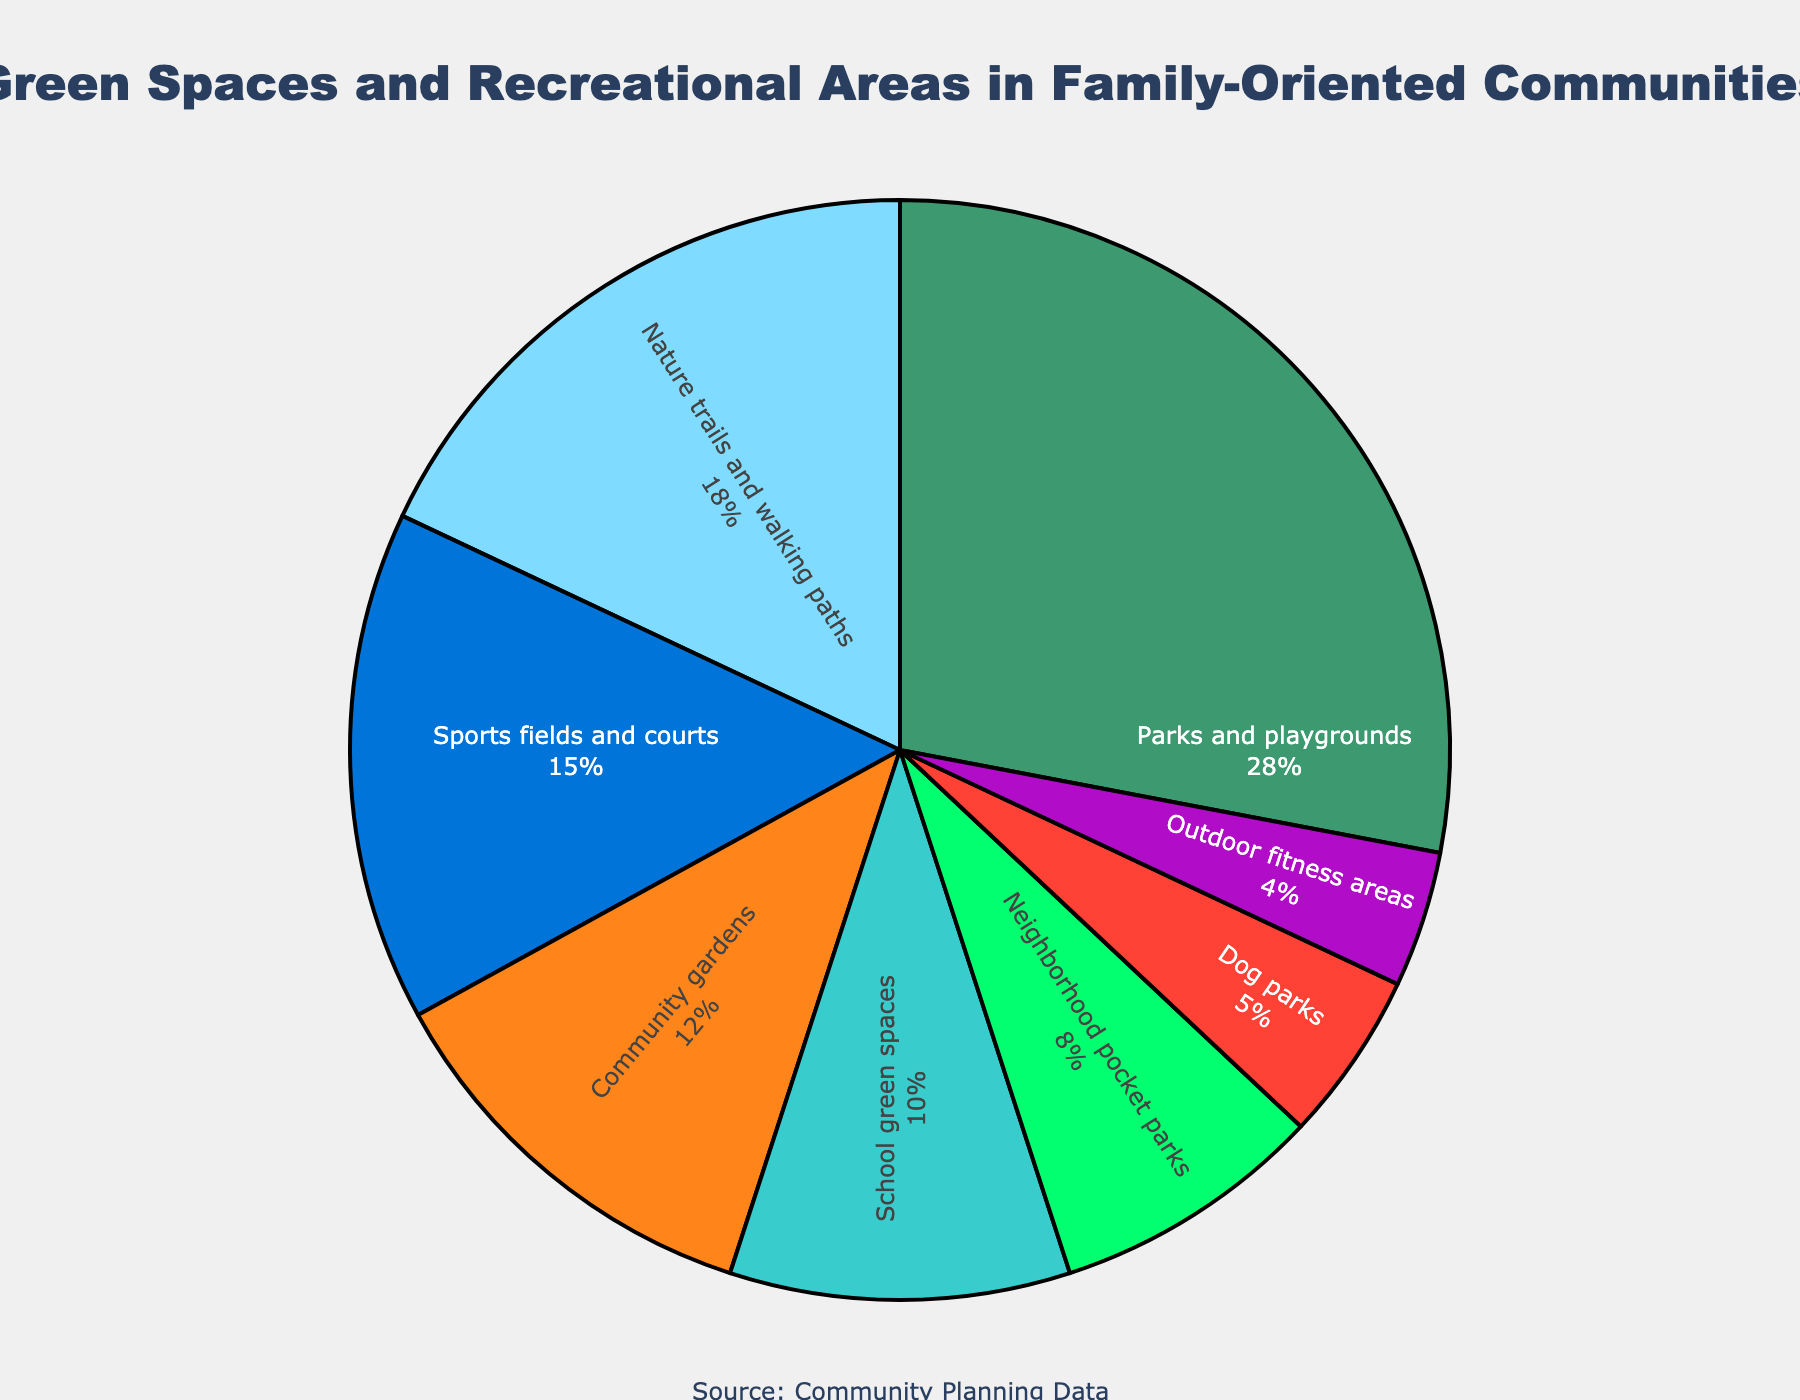What is the percentage of parks and playgrounds compared to community gardens? Parks and playgrounds are 28% while community gardens are 12%. The difference is calculated by subtracting 12 from 28.
Answer: 16% What is the total percentage of areas dedicated to parks and playgrounds, nature trails and walking paths, and neighborhood pocket parks? Sum the percentages of parks and playgrounds (28%), nature trails and walking paths (18%), and neighborhood pocket parks (8%). This equals 28 + 18 + 8.
Answer: 54% Which type of green space has the highest allocation? By looking at the pie chart, parks and playgrounds have the highest percentage allocation at 28%.
Answer: Parks and playgrounds Are school green spaces allocated more than or less than dog parks? School green spaces have a percentage of 10% while dog parks have a percentage of 5%. Therefore, school green spaces are allocated more.
Answer: More How much more percentage is allocated to sports fields and courts compared to dog parks? Sports fields and courts are 15% and dog parks are 5%. The difference is calculated by subtracting 5 from 15.
Answer: 10% What is the average percentage of community gardens, outdoor fitness areas, and sports fields and courts? Add the percentages of community gardens (12%), outdoor fitness areas (4%), and sports fields and courts (15%), then divide by 3. Thus, (12 + 4 + 15) / 3.
Answer: 10.33% What is the combined percentage for school green spaces and neighborhood pocket parks? Adding the percentages of school green spaces (10%) and neighborhood pocket parks (8%) gives 10 + 8.
Answer: 18% Which category is allocated the smallest percentage and what is it? The pie chart shows that outdoor fitness areas have the smallest percentage allocation of 4%.
Answer: Outdoor fitness areas Is the percentage of nature trails and walking paths higher or lower than school green spaces? Nature trails and walking paths have a percentage of 18% while school green spaces have a percentage of 10%. Nature trails and walking paths have a higher percentage.
Answer: Higher How does the allocation for community gardens compare to the allocation for neighborhood pocket parks? Community gardens have 12% allocation while neighborhood pocket parks have 8% allocation. The difference can be found by subtracting 8 from 12.
Answer: 4% higher 